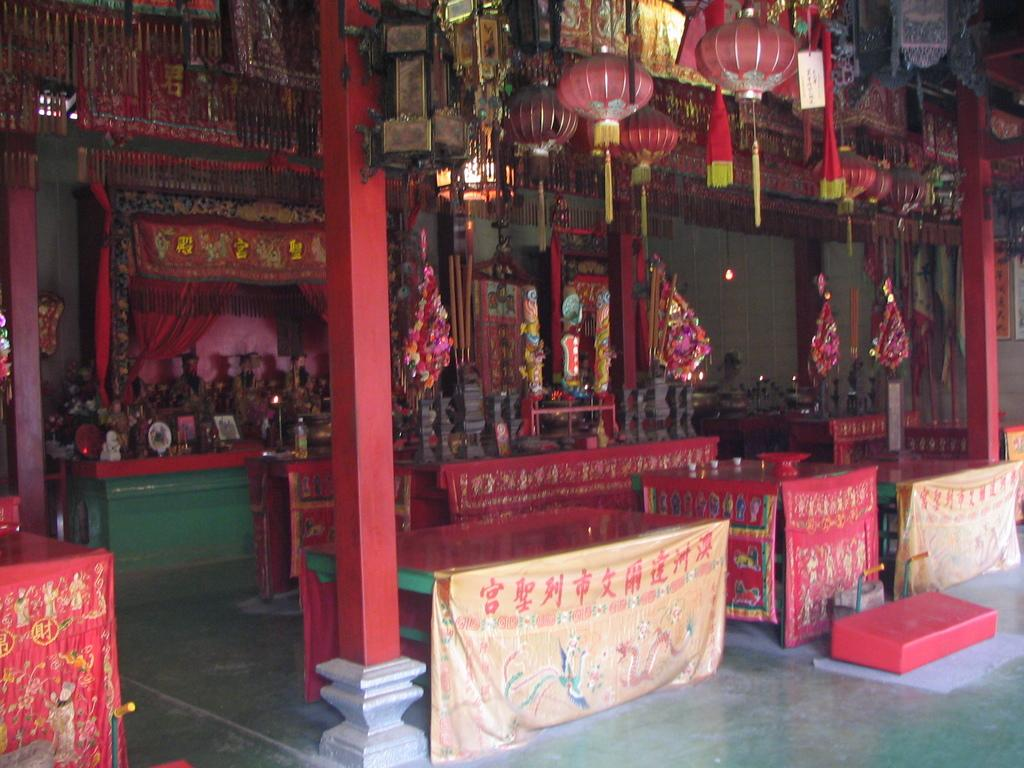What objects can be seen in the foreground of the image? There are tables, pillars, bouquets, sculptures, and lanterns hanging on the top in the foreground of the image. Can you describe the tables in the image? The tables are located in the foreground of the image. What type of decorations are present in the foreground of the image? Bouquets and sculptures are present as decorations in the foreground of the image. How are the lanterns positioned in the image? The lanterns are hanging on the top in the foreground of the image. What type of pickle is being served on the tables in the image? There is no pickle present in the image; the tables are not serving food. Can you describe the stew being cooked in the sculptures in the image? There is no stew being cooked in the sculptures in the image; the sculptures are decorative objects. 